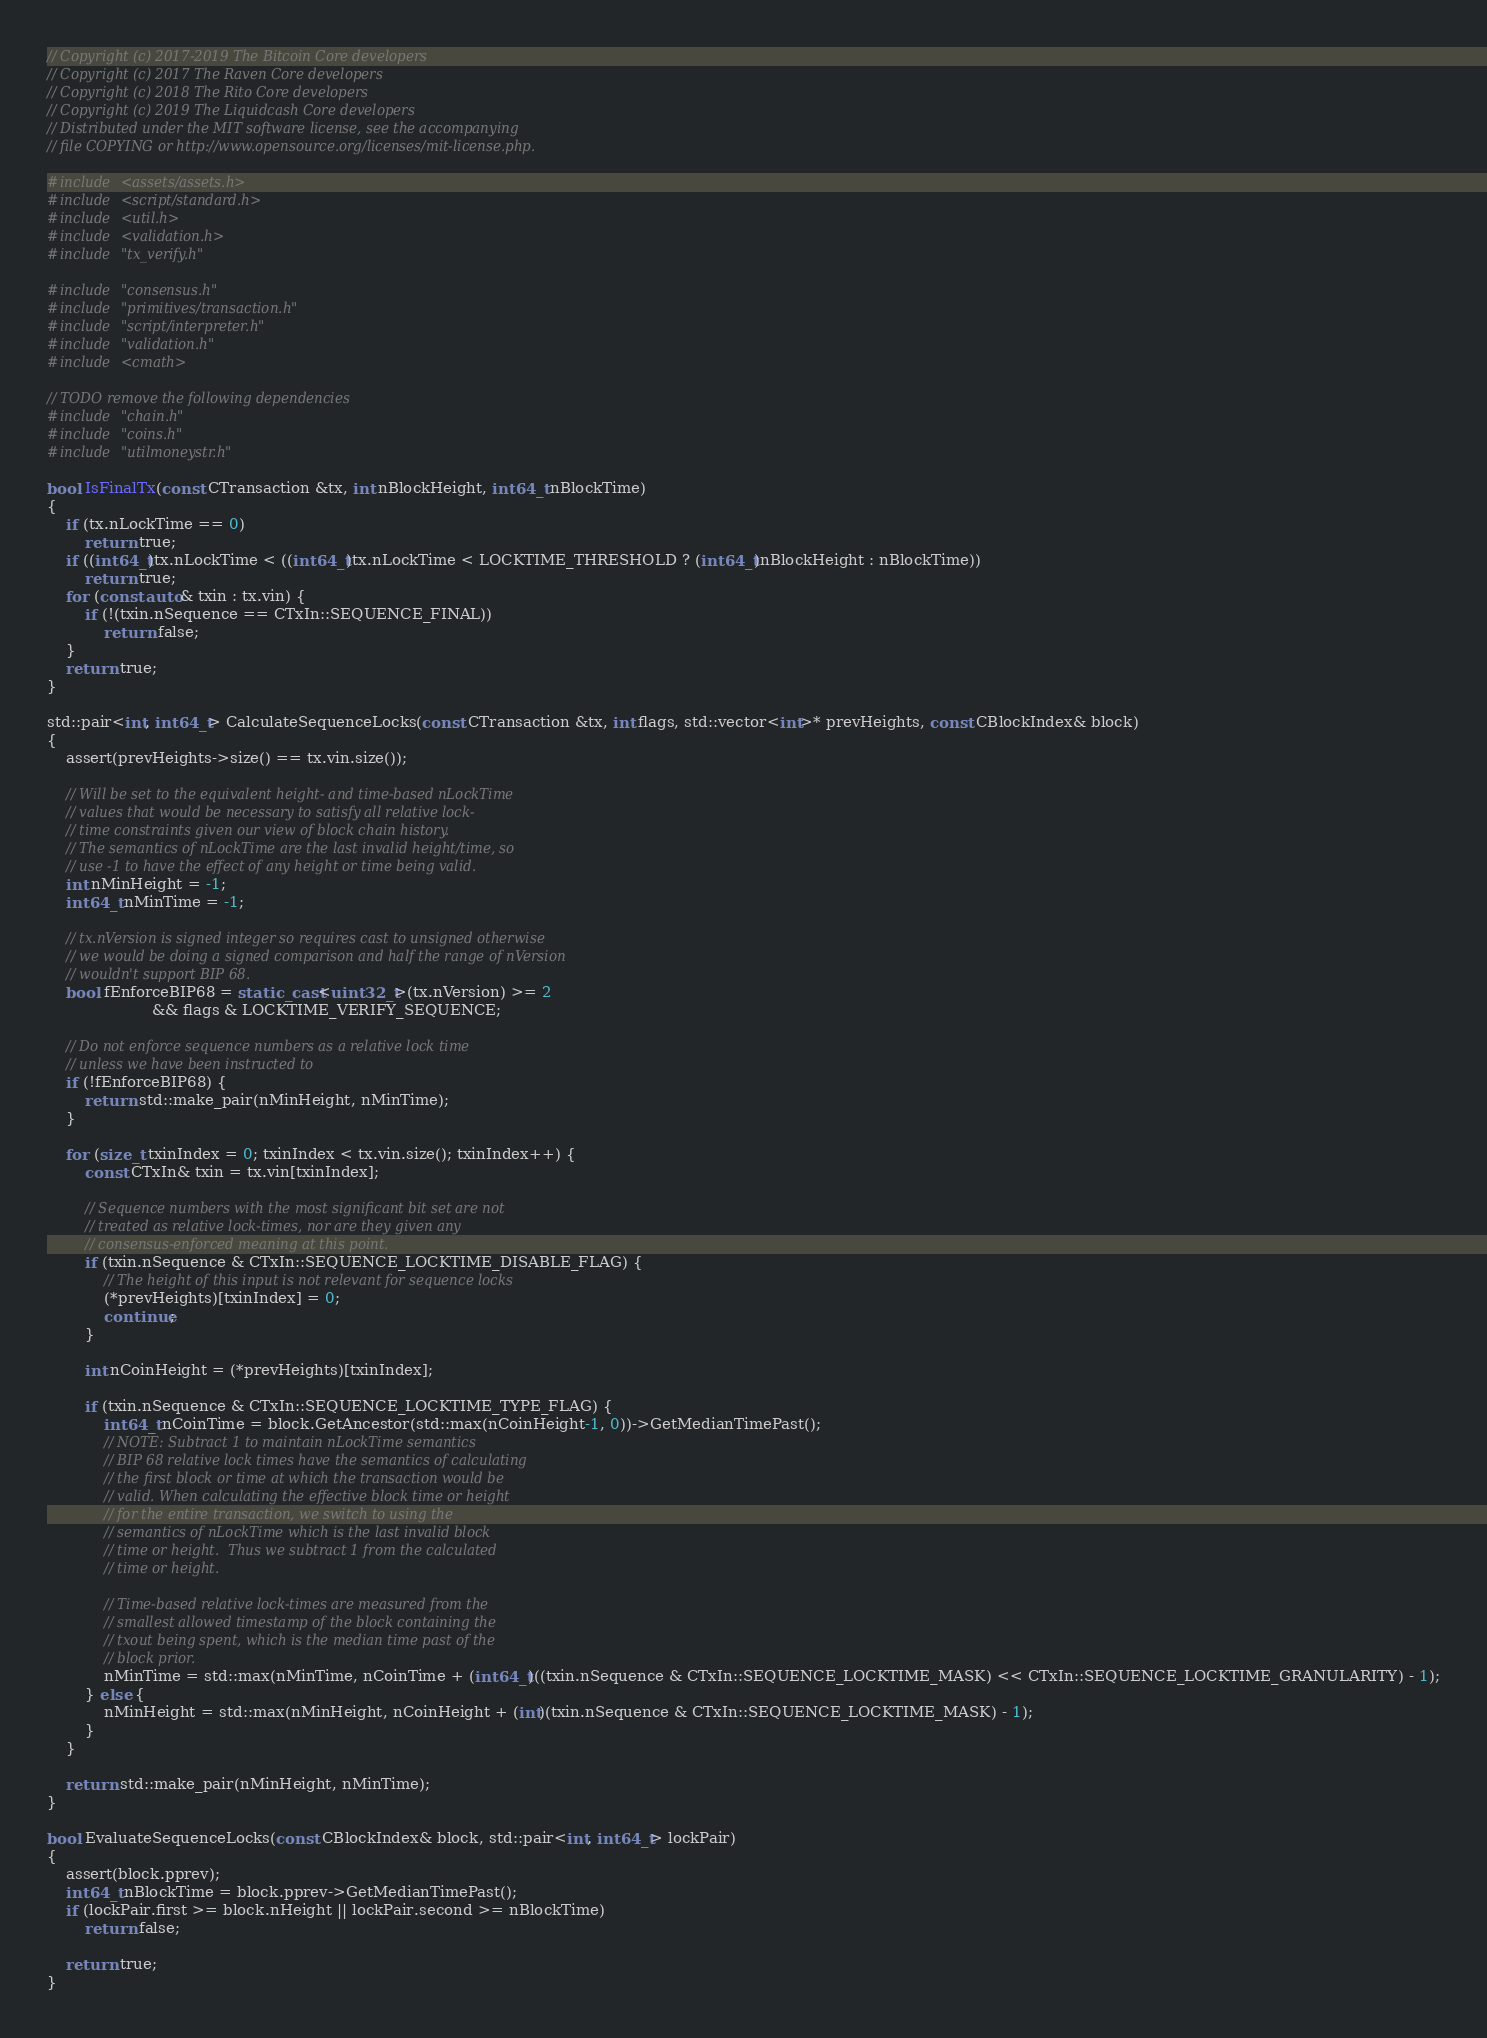Convert code to text. <code><loc_0><loc_0><loc_500><loc_500><_C++_>// Copyright (c) 2017-2019 The Bitcoin Core developers
// Copyright (c) 2017 The Raven Core developers
// Copyright (c) 2018 The Rito Core developers
// Copyright (c) 2019 The Liquidcash Core developers
// Distributed under the MIT software license, see the accompanying
// file COPYING or http://www.opensource.org/licenses/mit-license.php.

#include <assets/assets.h>
#include <script/standard.h>
#include <util.h>
#include <validation.h>
#include "tx_verify.h"

#include "consensus.h"
#include "primitives/transaction.h"
#include "script/interpreter.h"
#include "validation.h"
#include <cmath>

// TODO remove the following dependencies
#include "chain.h"
#include "coins.h"
#include "utilmoneystr.h"

bool IsFinalTx(const CTransaction &tx, int nBlockHeight, int64_t nBlockTime)
{
    if (tx.nLockTime == 0)
        return true;
    if ((int64_t)tx.nLockTime < ((int64_t)tx.nLockTime < LOCKTIME_THRESHOLD ? (int64_t)nBlockHeight : nBlockTime))
        return true;
    for (const auto& txin : tx.vin) {
        if (!(txin.nSequence == CTxIn::SEQUENCE_FINAL))
            return false;
    }
    return true;
}

std::pair<int, int64_t> CalculateSequenceLocks(const CTransaction &tx, int flags, std::vector<int>* prevHeights, const CBlockIndex& block)
{
    assert(prevHeights->size() == tx.vin.size());

    // Will be set to the equivalent height- and time-based nLockTime
    // values that would be necessary to satisfy all relative lock-
    // time constraints given our view of block chain history.
    // The semantics of nLockTime are the last invalid height/time, so
    // use -1 to have the effect of any height or time being valid.
    int nMinHeight = -1;
    int64_t nMinTime = -1;

    // tx.nVersion is signed integer so requires cast to unsigned otherwise
    // we would be doing a signed comparison and half the range of nVersion
    // wouldn't support BIP 68.
    bool fEnforceBIP68 = static_cast<uint32_t>(tx.nVersion) >= 2
                      && flags & LOCKTIME_VERIFY_SEQUENCE;

    // Do not enforce sequence numbers as a relative lock time
    // unless we have been instructed to
    if (!fEnforceBIP68) {
        return std::make_pair(nMinHeight, nMinTime);
    }

    for (size_t txinIndex = 0; txinIndex < tx.vin.size(); txinIndex++) {
        const CTxIn& txin = tx.vin[txinIndex];

        // Sequence numbers with the most significant bit set are not
        // treated as relative lock-times, nor are they given any
        // consensus-enforced meaning at this point.
        if (txin.nSequence & CTxIn::SEQUENCE_LOCKTIME_DISABLE_FLAG) {
            // The height of this input is not relevant for sequence locks
            (*prevHeights)[txinIndex] = 0;
            continue;
        }

        int nCoinHeight = (*prevHeights)[txinIndex];

        if (txin.nSequence & CTxIn::SEQUENCE_LOCKTIME_TYPE_FLAG) {
            int64_t nCoinTime = block.GetAncestor(std::max(nCoinHeight-1, 0))->GetMedianTimePast();
            // NOTE: Subtract 1 to maintain nLockTime semantics
            // BIP 68 relative lock times have the semantics of calculating
            // the first block or time at which the transaction would be
            // valid. When calculating the effective block time or height
            // for the entire transaction, we switch to using the
            // semantics of nLockTime which is the last invalid block
            // time or height.  Thus we subtract 1 from the calculated
            // time or height.

            // Time-based relative lock-times are measured from the
            // smallest allowed timestamp of the block containing the
            // txout being spent, which is the median time past of the
            // block prior.
            nMinTime = std::max(nMinTime, nCoinTime + (int64_t)((txin.nSequence & CTxIn::SEQUENCE_LOCKTIME_MASK) << CTxIn::SEQUENCE_LOCKTIME_GRANULARITY) - 1);
        } else {
            nMinHeight = std::max(nMinHeight, nCoinHeight + (int)(txin.nSequence & CTxIn::SEQUENCE_LOCKTIME_MASK) - 1);
        }
    }

    return std::make_pair(nMinHeight, nMinTime);
}

bool EvaluateSequenceLocks(const CBlockIndex& block, std::pair<int, int64_t> lockPair)
{
    assert(block.pprev);
    int64_t nBlockTime = block.pprev->GetMedianTimePast();
    if (lockPair.first >= block.nHeight || lockPair.second >= nBlockTime)
        return false;

    return true;
}
</code> 